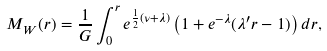<formula> <loc_0><loc_0><loc_500><loc_500>M _ { W } ( r ) = \frac { 1 } { G } \int _ { 0 } ^ { r } e ^ { \frac { 1 } { 2 } ( \nu + \lambda ) } \left ( 1 + e ^ { - \lambda } ( \lambda ^ { \prime } r - 1 ) \right ) d r ,</formula> 